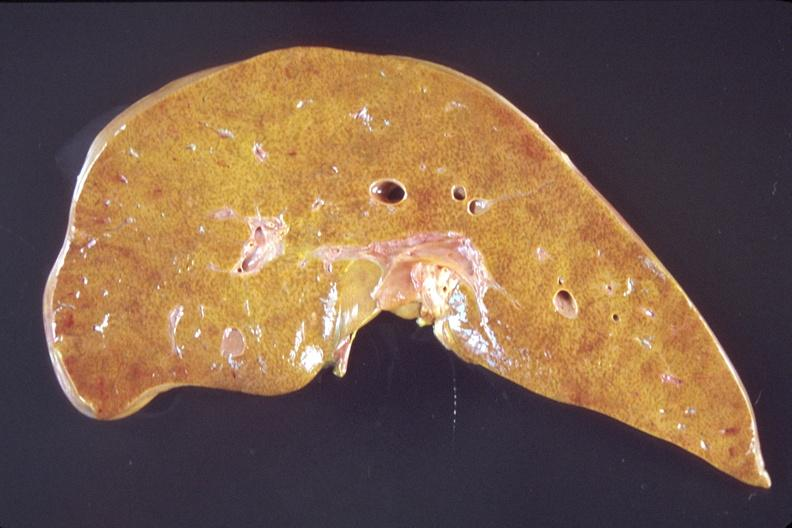what does this image show?
Answer the question using a single word or phrase. Liver 